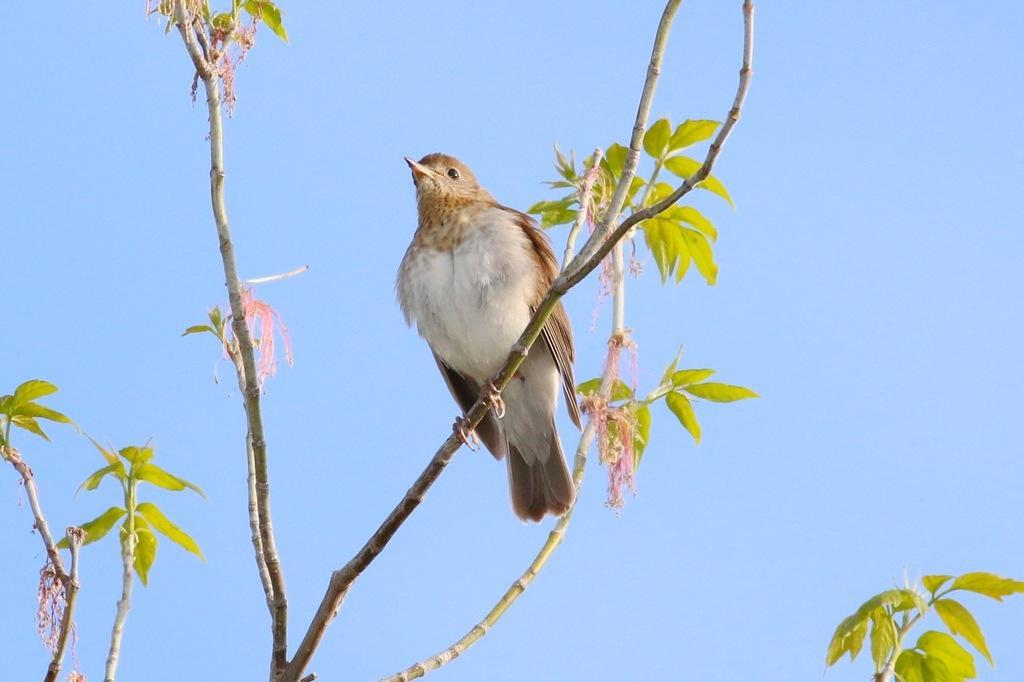In one or two sentences, can you explain what this image depicts? Bird is on branch. Here we can see green leaves. Background we can see the sky. Sky is in blue color.  